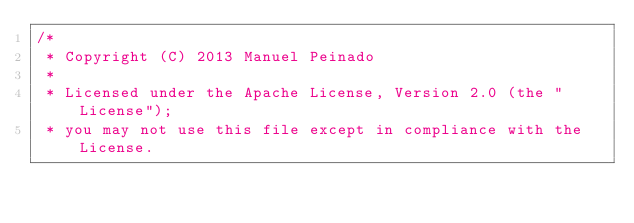<code> <loc_0><loc_0><loc_500><loc_500><_Java_>/*
 * Copyright (C) 2013 Manuel Peinado
 *
 * Licensed under the Apache License, Version 2.0 (the "License");
 * you may not use this file except in compliance with the License.</code> 